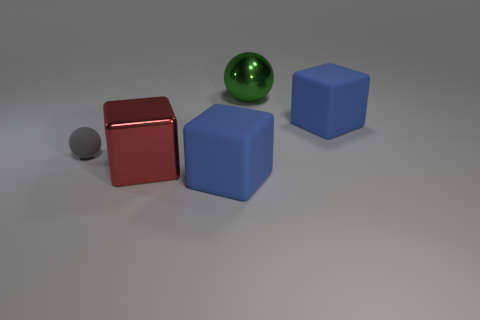Add 5 matte spheres. How many objects exist? 10 Subtract all cubes. How many objects are left? 2 Add 2 big matte blocks. How many big matte blocks exist? 4 Subtract 0 blue balls. How many objects are left? 5 Subtract all small gray matte things. Subtract all large things. How many objects are left? 0 Add 1 green metal objects. How many green metal objects are left? 2 